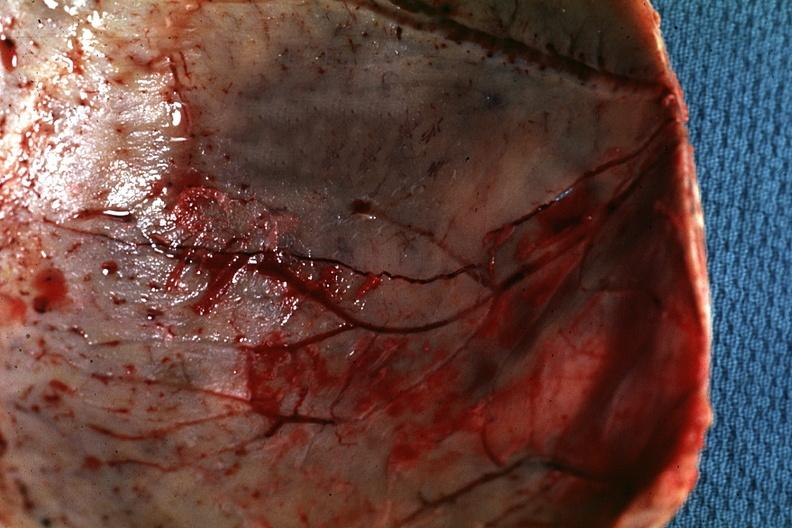what is present?
Answer the question using a single word or phrase. Bone 